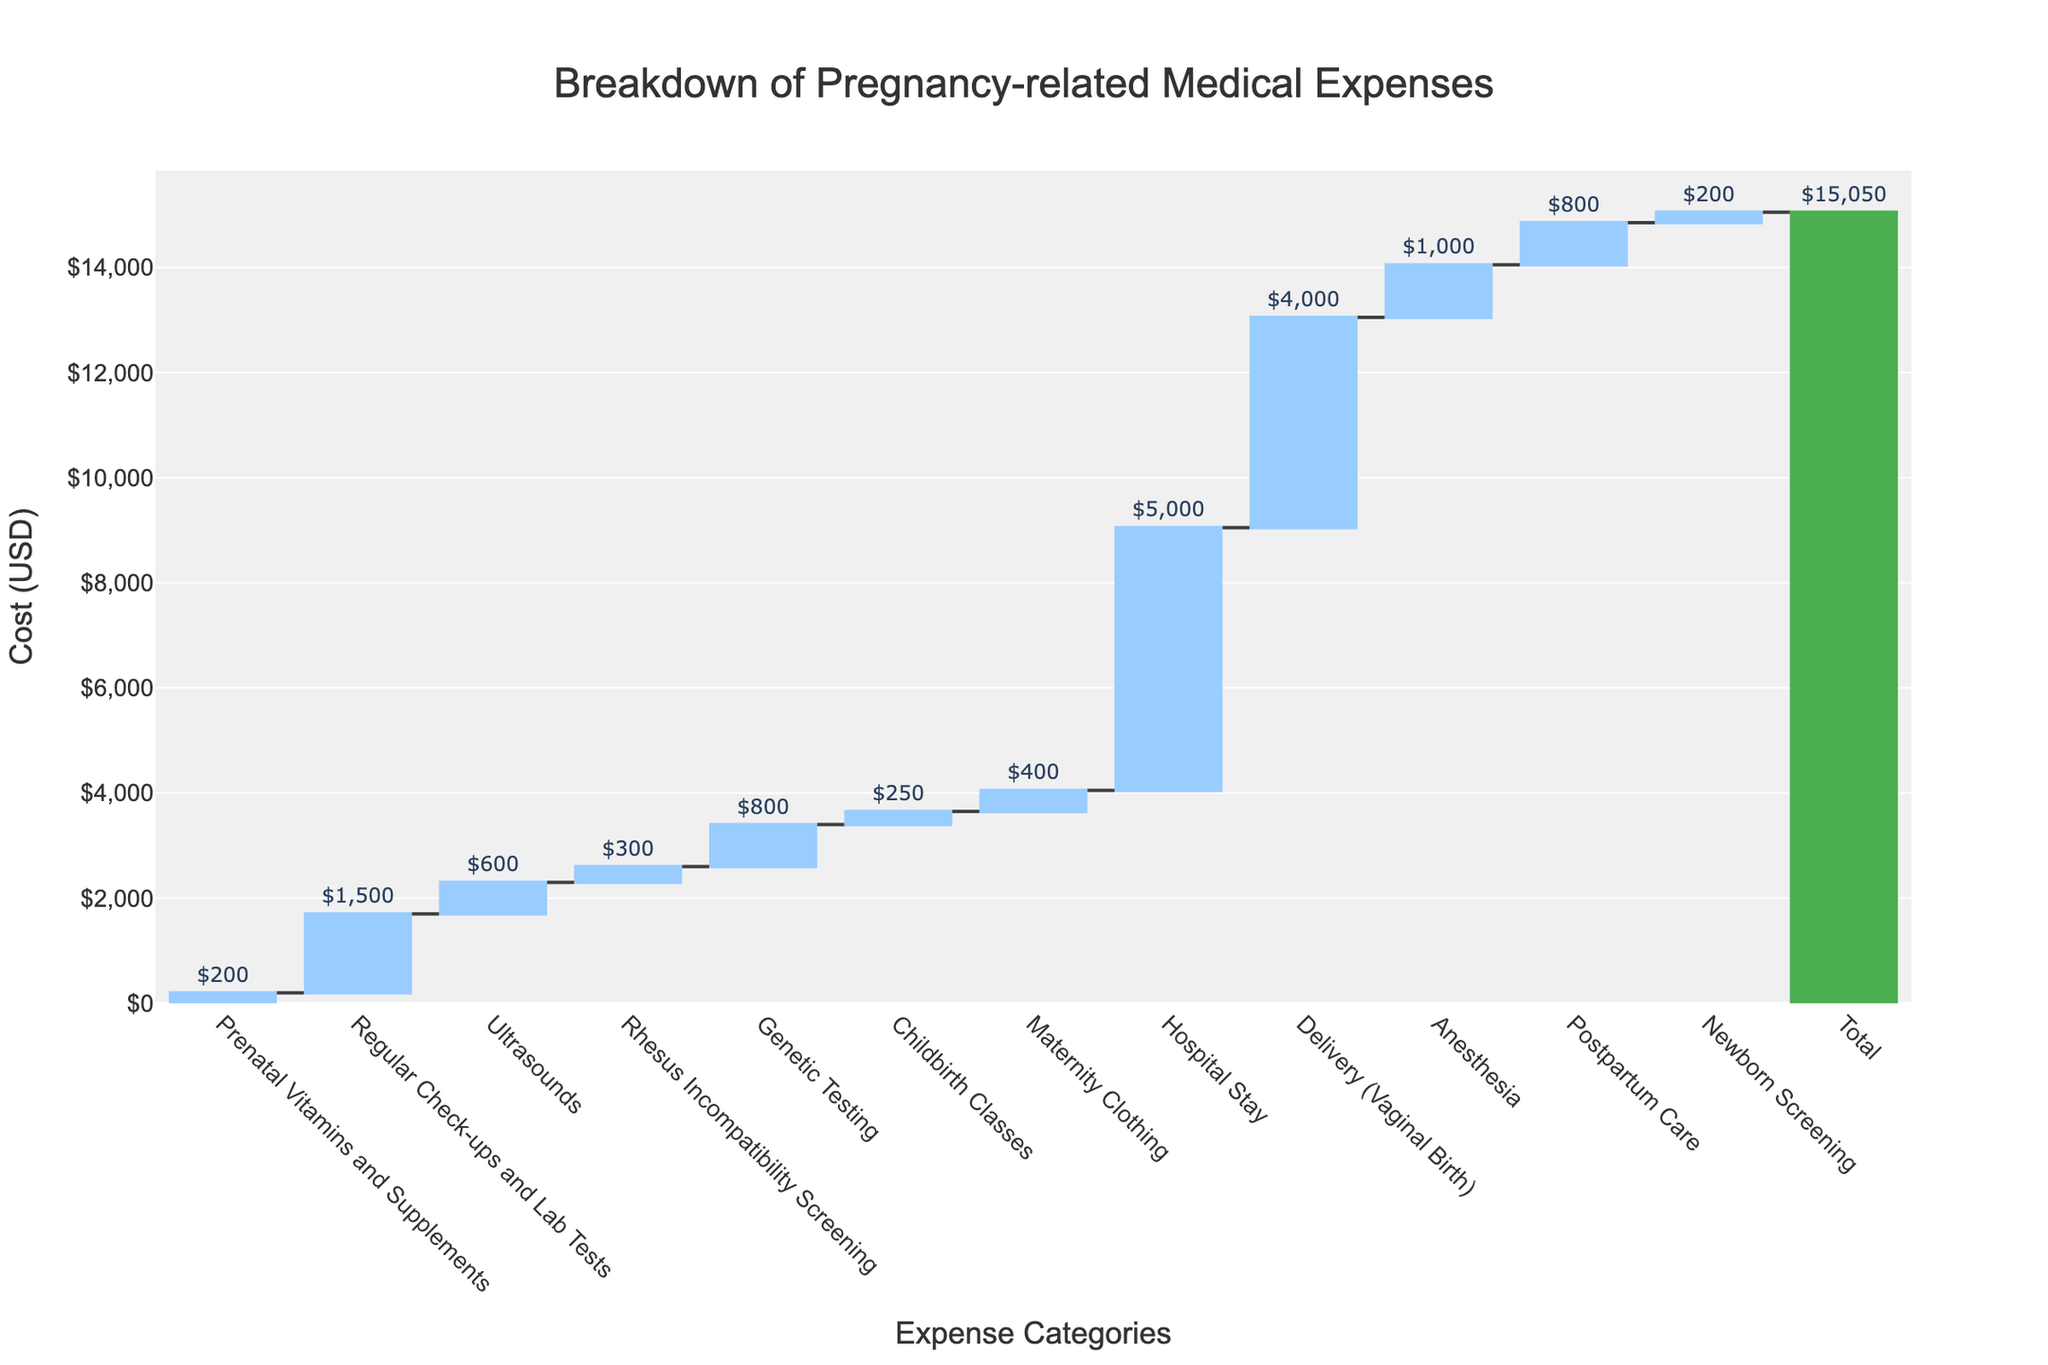What's the total cost of the medical expenses from conception to delivery? The total cost is shown in the chart's final bar, which sums up all individual expenses.
Answer: $15,050 How much do ultrasounds and genetic testing cost combined? The cost of ultrasounds is $600 and genetic testing is $800. Adding them together results in 600 + 800.
Answer: $1,400 Which category has the highest expense, and what is its value? The highest expense category is 'Hospital Stay', as it has the tallest bar.
Answer: $5,000 How does the cost of delivery (vaginal birth) compare to the cost of anesthesia? The delivery (vaginal birth) costs $4,000, while anesthesia costs $1,000. Delivery is $3,000 more expensive.
Answer: $3,000 more What is the combined cost of prenatal vitamins, maternity clothing, and postpartum care? Prenatal vitamins cost $200, maternity clothing costs $400, and postpartum care costs $800. Adding these together gives 200 + 400 + 800.
Answer: $1,400 Which category has the lowest cost, and what is its value? The lowest expense category is 'Newborn Screening', indicated by the shortest bar.
Answer: $200 What is the difference in cost between regular check-ups and lab tests versus childbirth classes? Regular check-ups and lab tests cost $1,500, while childbirth classes cost $250. The difference is 1,500 - 250.
Answer: $1,250 Which categories have expenses greater than $1,000 and what are their values? Categories with expenses greater than $1,000 are Regular Check-ups and Lab Tests ($1,500), Hospital Stay ($5,000), Delivery (Vaginal Birth) ($4,000), and Anesthesia ($1,000).
Answer: Four categories Is the cost of newborn screening more or less than that of prenatal vitamins and supplements? Newborn screening costs $200, whereas prenatal vitamins and supplements cost $200. Both categories have the same cost.
Answer: Same 